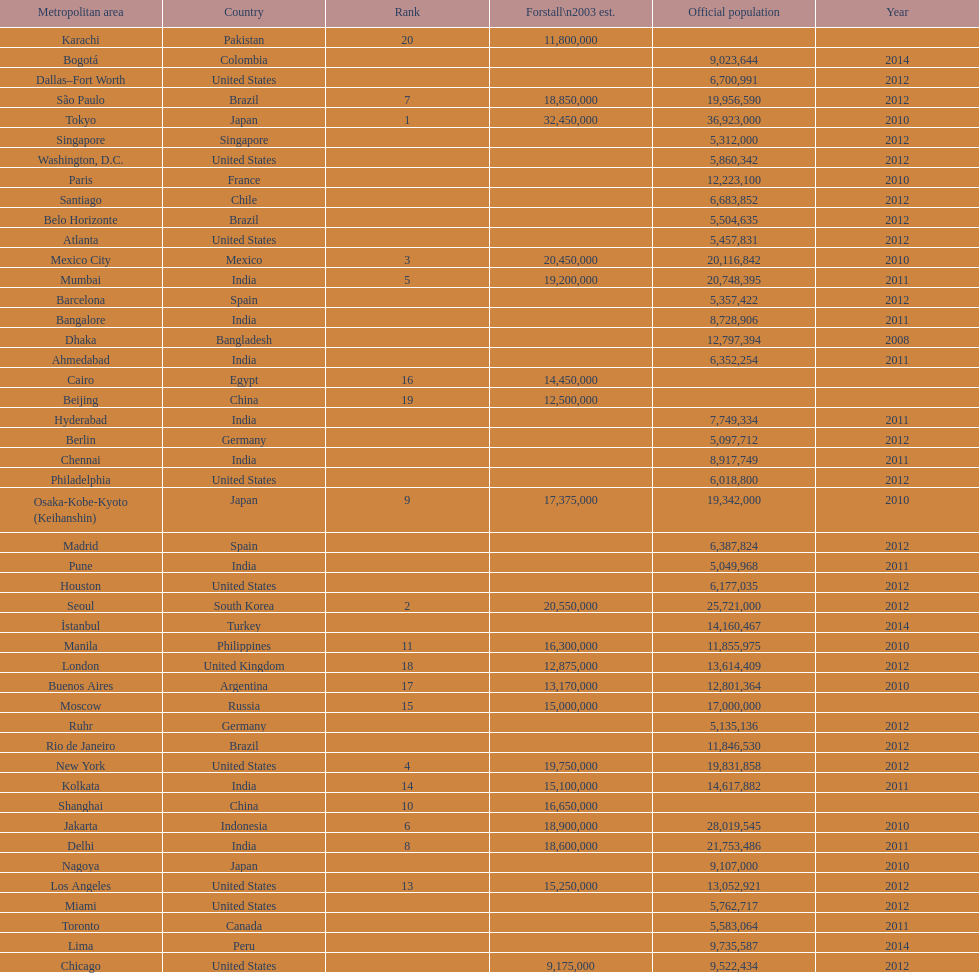What city was ranked first in 2003? Tokyo. 